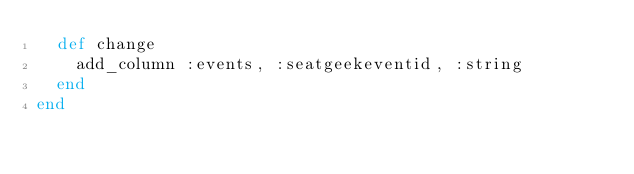<code> <loc_0><loc_0><loc_500><loc_500><_Ruby_>  def change
    add_column :events, :seatgeekeventid, :string
  end
end
</code> 